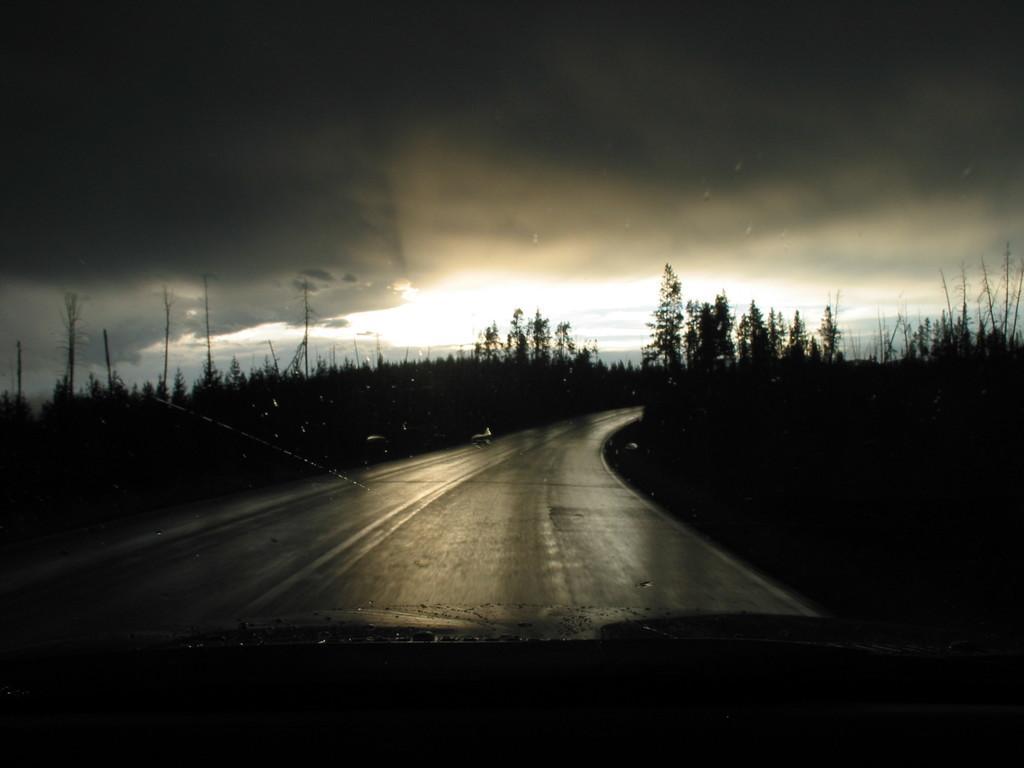Please provide a concise description of this image. In the image in the center, we can see the sky, clouds, trees, poles and road. 